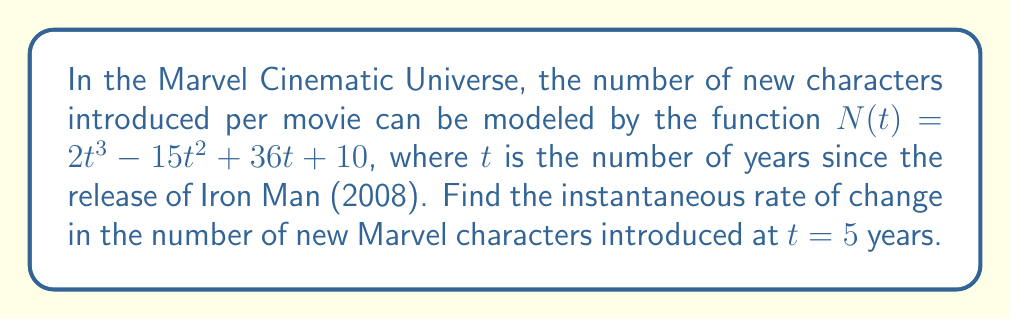Could you help me with this problem? To find the instantaneous rate of change, we need to calculate the derivative of the given function and evaluate it at $t = 5$.

Step 1: Find the derivative of $N(t)$.
$$N'(t) = \frac{d}{dt}(2t^3 - 15t^2 + 36t + 10)$$
$$N'(t) = 6t^2 - 30t + 36$$

Step 2: Evaluate $N'(t)$ at $t = 5$.
$$N'(5) = 6(5)^2 - 30(5) + 36$$
$$N'(5) = 6(25) - 150 + 36$$
$$N'(5) = 150 - 150 + 36$$
$$N'(5) = 36$$

The instantaneous rate of change at $t = 5$ years is 36 new characters per year.
Answer: 36 new characters/year 